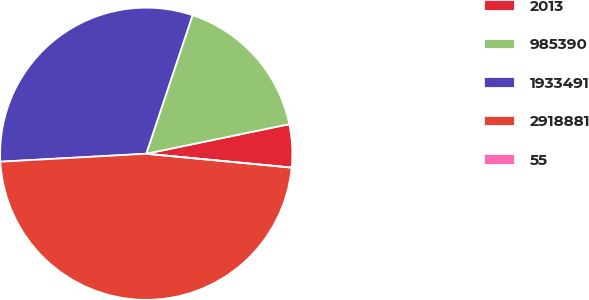<chart> <loc_0><loc_0><loc_500><loc_500><pie_chart><fcel>2013<fcel>985390<fcel>1933491<fcel>2918881<fcel>55<nl><fcel>4.76%<fcel>16.62%<fcel>31.0%<fcel>47.62%<fcel>0.0%<nl></chart> 